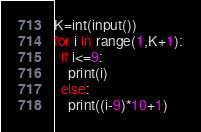Convert code to text. <code><loc_0><loc_0><loc_500><loc_500><_Python_>K=int(input())
for i in range(1,K+1):
  if i<=9:
    print(i)
  else:
    print((i-9)*10+1)</code> 